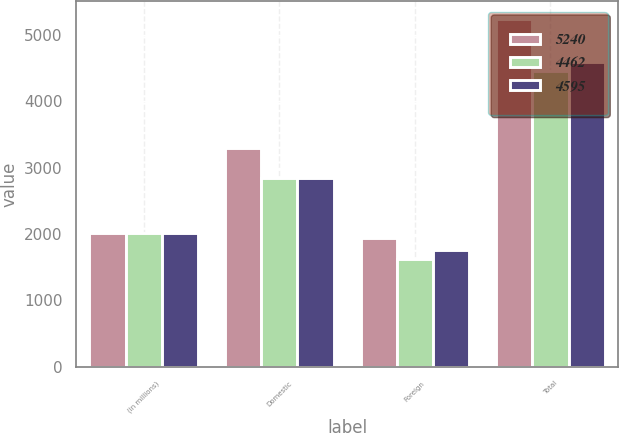Convert chart to OTSL. <chart><loc_0><loc_0><loc_500><loc_500><stacked_bar_chart><ecel><fcel>(in millions)<fcel>Domestic<fcel>Foreign<fcel>Total<nl><fcel>5240<fcel>2017<fcel>3298<fcel>1942<fcel>5240<nl><fcel>4462<fcel>2016<fcel>2837<fcel>1625<fcel>4462<nl><fcel>4595<fcel>2015<fcel>2840<fcel>1755<fcel>4595<nl></chart> 